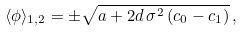<formula> <loc_0><loc_0><loc_500><loc_500>\langle \phi \rangle _ { 1 , 2 } = \pm \sqrt { a + 2 d \, \sigma ^ { 2 } \, ( c _ { 0 } - c _ { 1 } ) } \, ,</formula> 